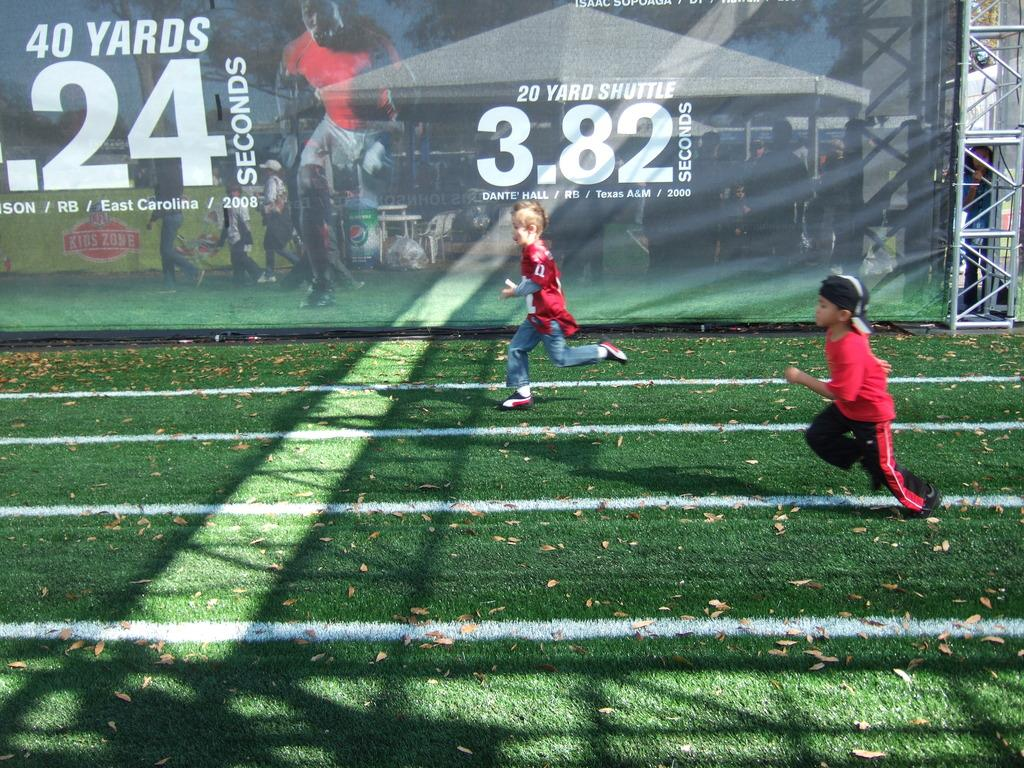<image>
Create a compact narrative representing the image presented. Youth running in front of a banner that has 20 yard shuttle in white letters. 